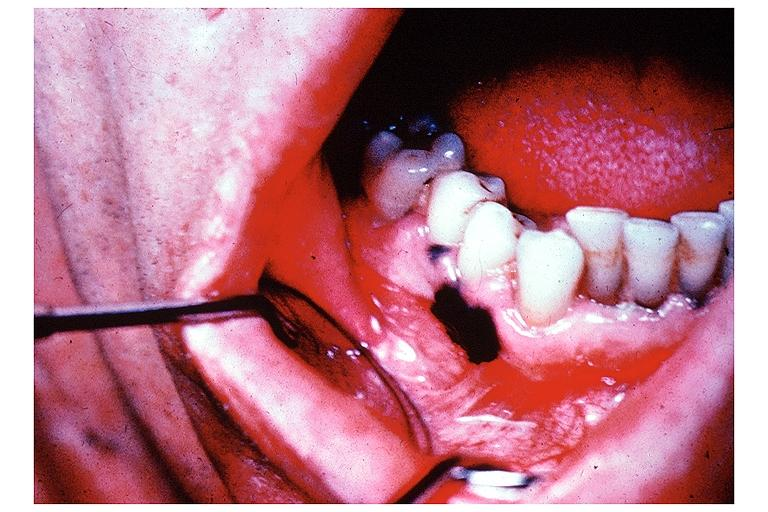s 7182 and 7183 present?
Answer the question using a single word or phrase. No 